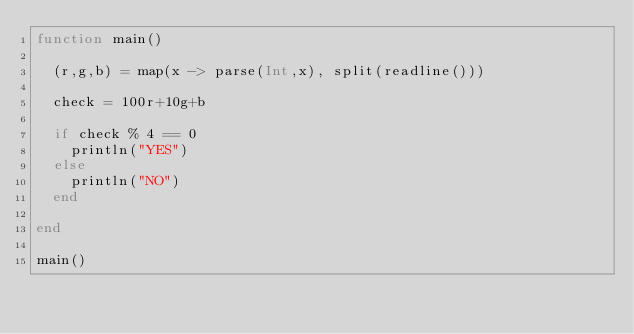Convert code to text. <code><loc_0><loc_0><loc_500><loc_500><_Julia_>function main()
  
  (r,g,b) = map(x -> parse(Int,x), split(readline()))
  
  check = 100r+10g+b
  
  if check % 4 == 0
    println("YES")
  else
    println("NO")
  end
  
end

main()</code> 